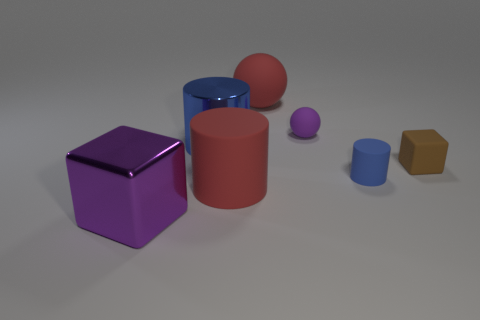Can you describe the textures of the objects shown? Certainly! The objects appear to have various textures. The purple cube and the red cylinder have a matte finish, suggesting they have a slightly rough texture. The large red sphere and the smaller purple sphere seem to have a smooth, shiny surface, indicative of a glossy texture. Lastly, the brown hexagonal prism and the small blue cylinder have a more muted, less reflective finish, implying a less smooth surface. 